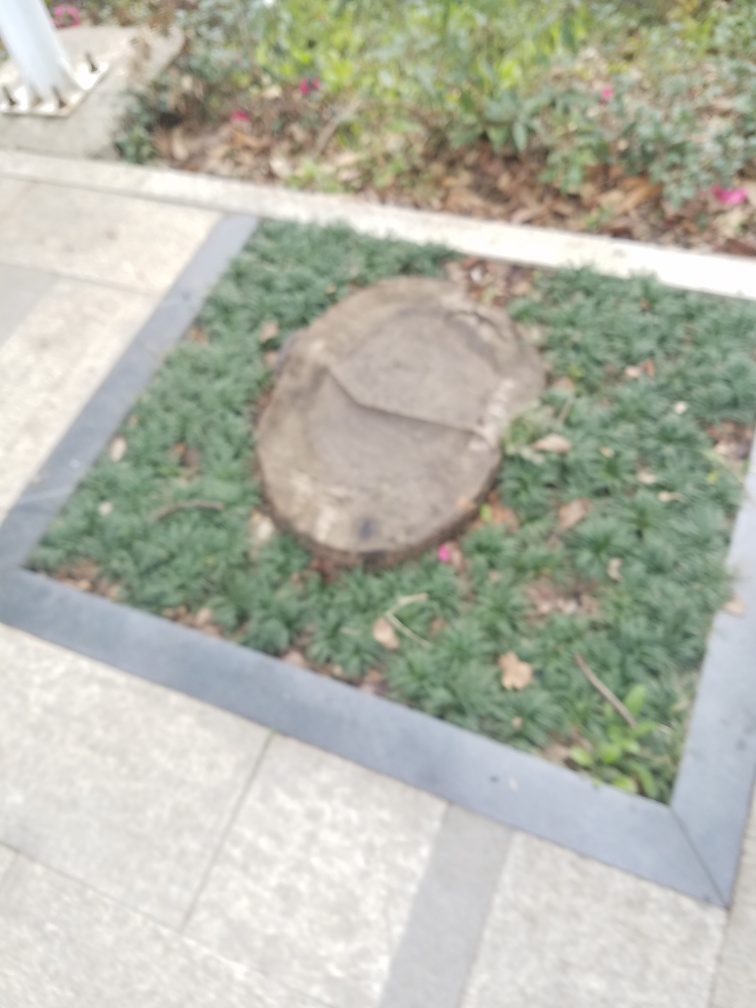What is the main object in this blurred image? Due to the blurriness of the image, it's challenging to identify with certainty. It appears there could be a large rock or a round object surrounded by greenery, potentially a garden or landscaped area. 